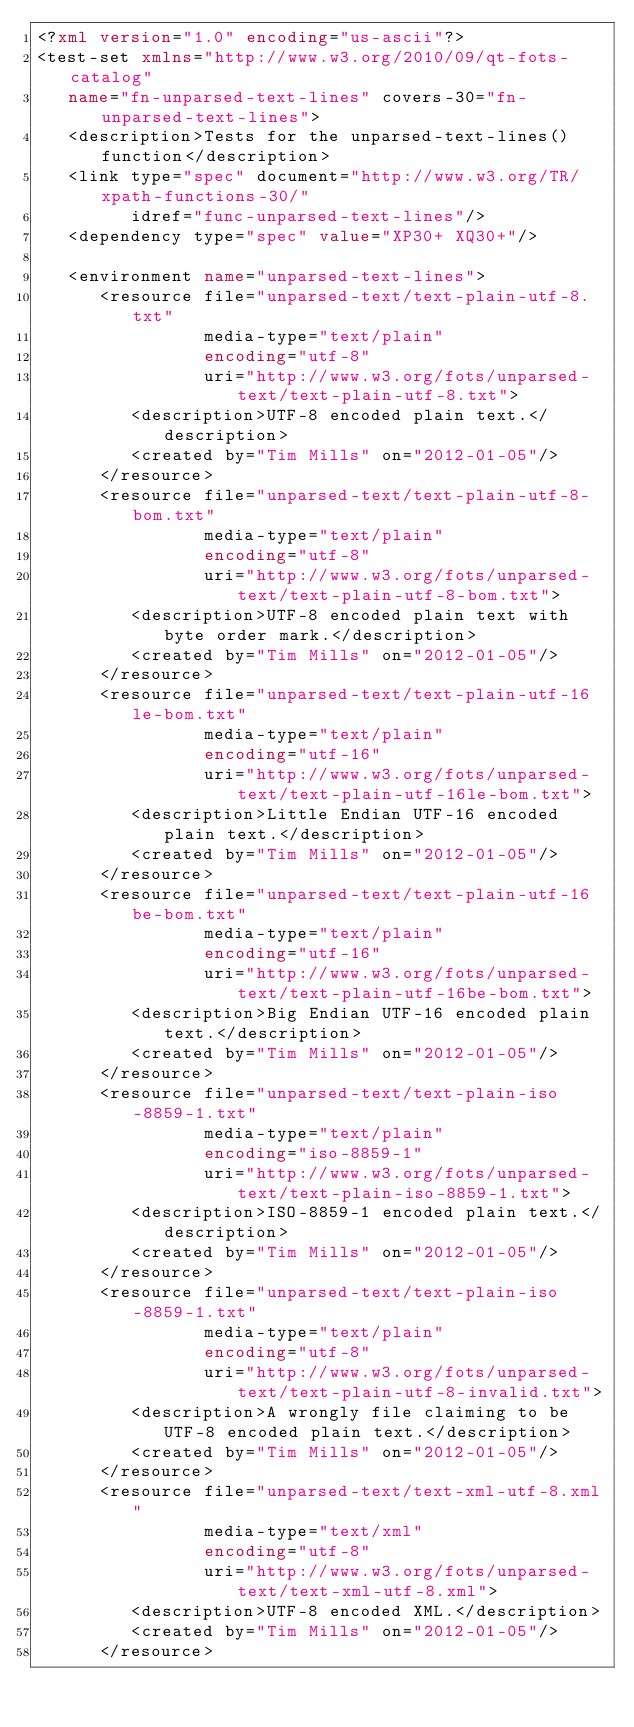Convert code to text. <code><loc_0><loc_0><loc_500><loc_500><_XML_><?xml version="1.0" encoding="us-ascii"?>
<test-set xmlns="http://www.w3.org/2010/09/qt-fots-catalog" 
   name="fn-unparsed-text-lines" covers-30="fn-unparsed-text-lines">
   <description>Tests for the unparsed-text-lines() function</description>
   <link type="spec" document="http://www.w3.org/TR/xpath-functions-30/"
         idref="func-unparsed-text-lines"/>
   <dependency type="spec" value="XP30+ XQ30+"/>

   <environment name="unparsed-text-lines">
      <resource file="unparsed-text/text-plain-utf-8.txt"
                media-type="text/plain" 
                encoding="utf-8"
                uri="http://www.w3.org/fots/unparsed-text/text-plain-utf-8.txt">
         <description>UTF-8 encoded plain text.</description>
         <created by="Tim Mills" on="2012-01-05"/>
      </resource>
      <resource file="unparsed-text/text-plain-utf-8-bom.txt"
                media-type="text/plain" 
                encoding="utf-8"
                uri="http://www.w3.org/fots/unparsed-text/text-plain-utf-8-bom.txt">
         <description>UTF-8 encoded plain text with byte order mark.</description>
         <created by="Tim Mills" on="2012-01-05"/>
      </resource>
      <resource file="unparsed-text/text-plain-utf-16le-bom.txt"
                media-type="text/plain" 
                encoding="utf-16"
                uri="http://www.w3.org/fots/unparsed-text/text-plain-utf-16le-bom.txt">
         <description>Little Endian UTF-16 encoded plain text.</description>
         <created by="Tim Mills" on="2012-01-05"/>
      </resource>
      <resource file="unparsed-text/text-plain-utf-16be-bom.txt"
                media-type="text/plain" 
                encoding="utf-16"
                uri="http://www.w3.org/fots/unparsed-text/text-plain-utf-16be-bom.txt">
         <description>Big Endian UTF-16 encoded plain text.</description>
         <created by="Tim Mills" on="2012-01-05"/>
      </resource>
      <resource file="unparsed-text/text-plain-iso-8859-1.txt" 
                media-type="text/plain" 
                encoding="iso-8859-1"
                uri="http://www.w3.org/fots/unparsed-text/text-plain-iso-8859-1.txt">
         <description>ISO-8859-1 encoded plain text.</description>
         <created by="Tim Mills" on="2012-01-05"/>
      </resource>
      <resource file="unparsed-text/text-plain-iso-8859-1.txt"
                media-type="text/plain" 
                encoding="utf-8"
                uri="http://www.w3.org/fots/unparsed-text/text-plain-utf-8-invalid.txt">
         <description>A wrongly file claiming to be UTF-8 encoded plain text.</description>
         <created by="Tim Mills" on="2012-01-05"/>
      </resource>
      <resource file="unparsed-text/text-xml-utf-8.xml"
                media-type="text/xml" 
                encoding="utf-8"
                uri="http://www.w3.org/fots/unparsed-text/text-xml-utf-8.xml">
         <description>UTF-8 encoded XML.</description>
         <created by="Tim Mills" on="2012-01-05"/>
      </resource></code> 